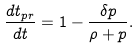<formula> <loc_0><loc_0><loc_500><loc_500>\frac { d t _ { p r } } { d t } = 1 - \frac { \delta p } { \rho + p } .</formula> 